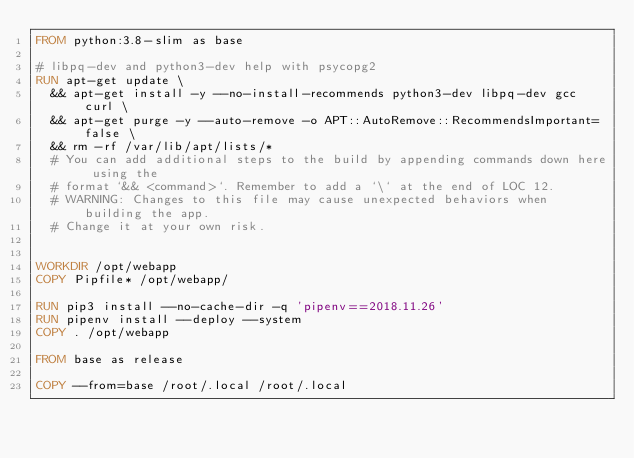<code> <loc_0><loc_0><loc_500><loc_500><_Dockerfile_>FROM python:3.8-slim as base

# libpq-dev and python3-dev help with psycopg2
RUN apt-get update \
  && apt-get install -y --no-install-recommends python3-dev libpq-dev gcc curl \
  && apt-get purge -y --auto-remove -o APT::AutoRemove::RecommendsImportant=false \
  && rm -rf /var/lib/apt/lists/*
  # You can add additional steps to the build by appending commands down here using the
  # format `&& <command>`. Remember to add a `\` at the end of LOC 12.
  # WARNING: Changes to this file may cause unexpected behaviors when building the app.
  # Change it at your own risk.


WORKDIR /opt/webapp
COPY Pipfile* /opt/webapp/

RUN pip3 install --no-cache-dir -q 'pipenv==2018.11.26' 
RUN pipenv install --deploy --system
COPY . /opt/webapp

FROM base as release

COPY --from=base /root/.local /root/.local</code> 